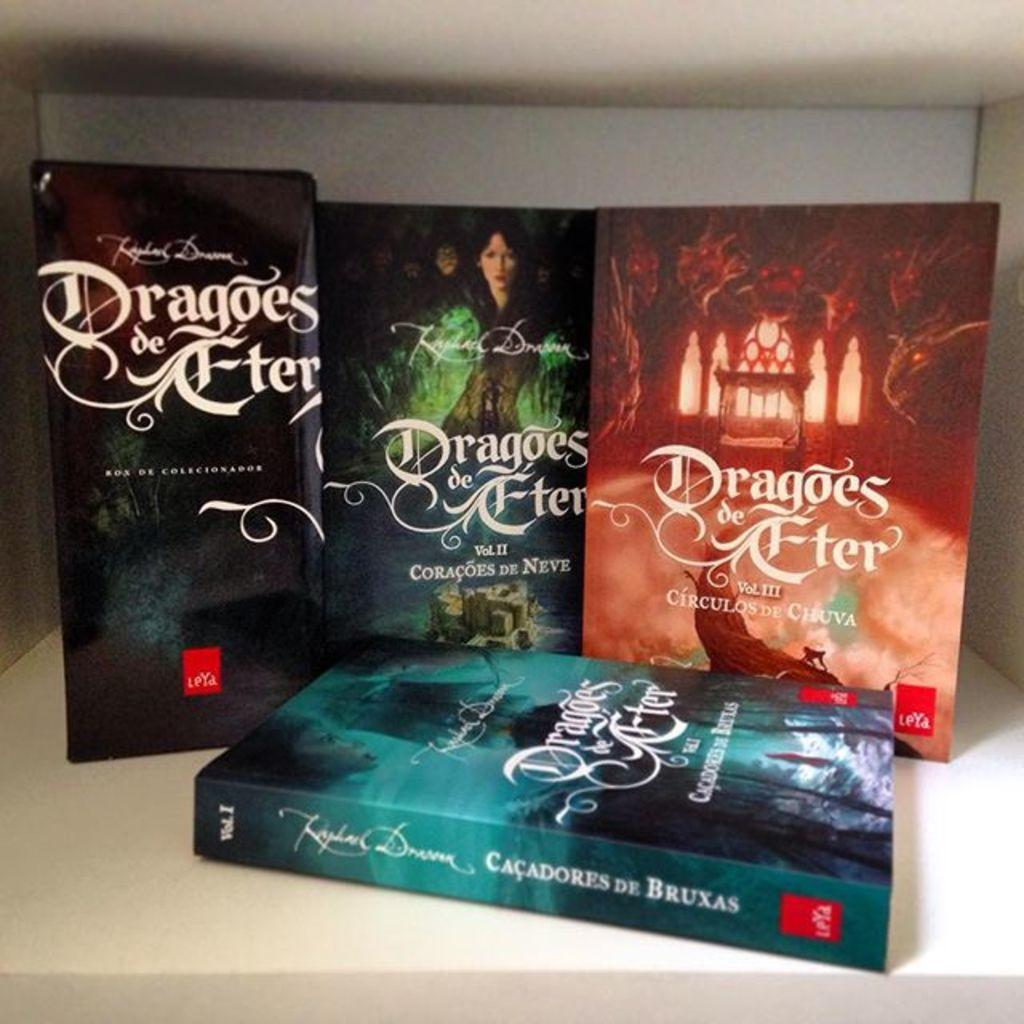<image>
Summarize the visual content of the image. Four Dragoes de Eter are displayed in a box. 